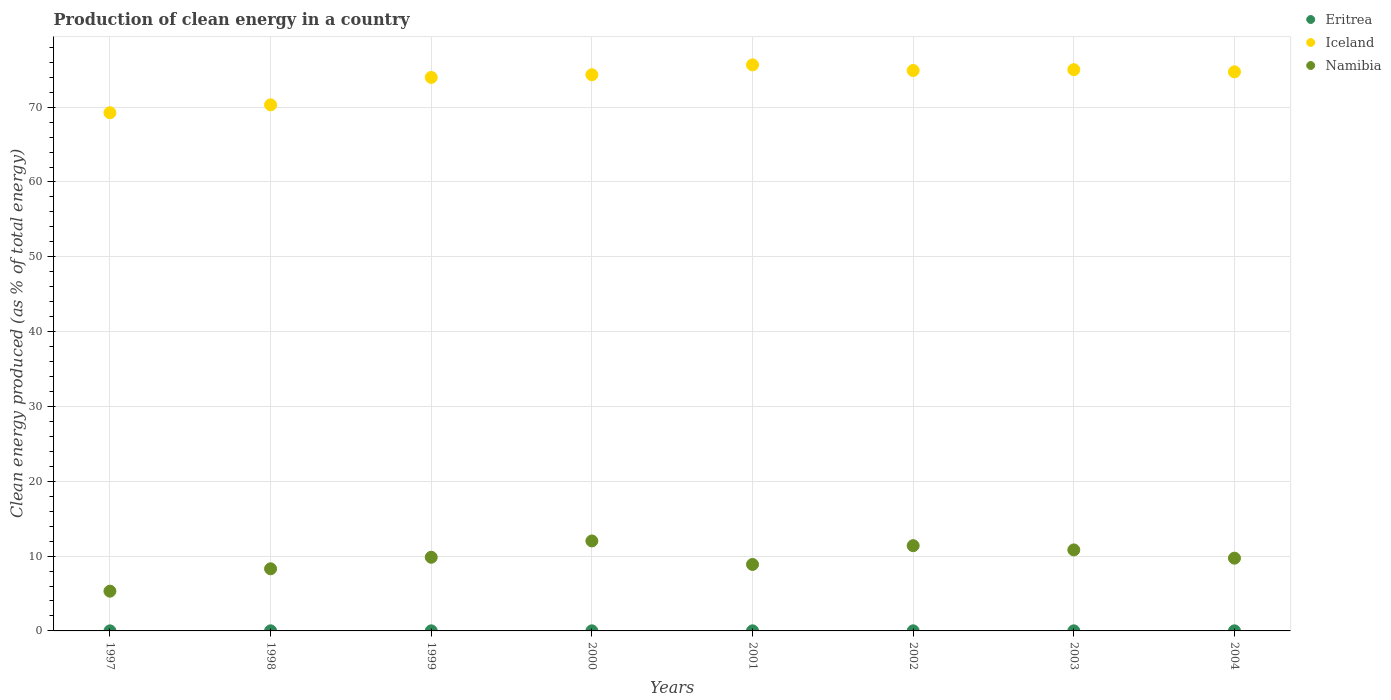How many different coloured dotlines are there?
Ensure brevity in your answer.  3. What is the percentage of clean energy produced in Eritrea in 2002?
Provide a short and direct response. 0.01. Across all years, what is the maximum percentage of clean energy produced in Namibia?
Provide a short and direct response. 12.02. Across all years, what is the minimum percentage of clean energy produced in Namibia?
Your answer should be compact. 5.31. In which year was the percentage of clean energy produced in Namibia maximum?
Provide a succinct answer. 2000. In which year was the percentage of clean energy produced in Eritrea minimum?
Ensure brevity in your answer.  1997. What is the total percentage of clean energy produced in Iceland in the graph?
Keep it short and to the point. 588.17. What is the difference between the percentage of clean energy produced in Eritrea in 1999 and that in 2001?
Keep it short and to the point. 0. What is the difference between the percentage of clean energy produced in Namibia in 1997 and the percentage of clean energy produced in Iceland in 1999?
Your answer should be compact. -68.66. What is the average percentage of clean energy produced in Eritrea per year?
Ensure brevity in your answer.  0.01. In the year 2001, what is the difference between the percentage of clean energy produced in Namibia and percentage of clean energy produced in Iceland?
Offer a terse response. -66.77. In how many years, is the percentage of clean energy produced in Iceland greater than 16 %?
Provide a short and direct response. 8. What is the ratio of the percentage of clean energy produced in Iceland in 1998 to that in 1999?
Your answer should be very brief. 0.95. Is the percentage of clean energy produced in Namibia in 1997 less than that in 2003?
Your response must be concise. Yes. What is the difference between the highest and the second highest percentage of clean energy produced in Eritrea?
Keep it short and to the point. 0. What is the difference between the highest and the lowest percentage of clean energy produced in Eritrea?
Offer a very short reply. 0. Is the sum of the percentage of clean energy produced in Namibia in 2003 and 2004 greater than the maximum percentage of clean energy produced in Iceland across all years?
Offer a very short reply. No. Is it the case that in every year, the sum of the percentage of clean energy produced in Namibia and percentage of clean energy produced in Eritrea  is greater than the percentage of clean energy produced in Iceland?
Your response must be concise. No. Does the percentage of clean energy produced in Namibia monotonically increase over the years?
Offer a very short reply. No. How many dotlines are there?
Give a very brief answer. 3. How many years are there in the graph?
Make the answer very short. 8. What is the difference between two consecutive major ticks on the Y-axis?
Offer a terse response. 10. Does the graph contain any zero values?
Your response must be concise. No. How many legend labels are there?
Give a very brief answer. 3. What is the title of the graph?
Your response must be concise. Production of clean energy in a country. Does "Low income" appear as one of the legend labels in the graph?
Keep it short and to the point. No. What is the label or title of the X-axis?
Offer a very short reply. Years. What is the label or title of the Y-axis?
Your response must be concise. Clean energy produced (as % of total energy). What is the Clean energy produced (as % of total energy) of Eritrea in 1997?
Provide a succinct answer. 0.01. What is the Clean energy produced (as % of total energy) of Iceland in 1997?
Give a very brief answer. 69.26. What is the Clean energy produced (as % of total energy) in Namibia in 1997?
Your response must be concise. 5.31. What is the Clean energy produced (as % of total energy) in Eritrea in 1998?
Make the answer very short. 0.01. What is the Clean energy produced (as % of total energy) in Iceland in 1998?
Offer a terse response. 70.31. What is the Clean energy produced (as % of total energy) of Namibia in 1998?
Provide a short and direct response. 8.3. What is the Clean energy produced (as % of total energy) of Eritrea in 1999?
Ensure brevity in your answer.  0.01. What is the Clean energy produced (as % of total energy) of Iceland in 1999?
Your answer should be compact. 73.98. What is the Clean energy produced (as % of total energy) of Namibia in 1999?
Provide a succinct answer. 9.84. What is the Clean energy produced (as % of total energy) of Eritrea in 2000?
Keep it short and to the point. 0.01. What is the Clean energy produced (as % of total energy) in Iceland in 2000?
Your answer should be compact. 74.33. What is the Clean energy produced (as % of total energy) in Namibia in 2000?
Ensure brevity in your answer.  12.02. What is the Clean energy produced (as % of total energy) of Eritrea in 2001?
Give a very brief answer. 0.01. What is the Clean energy produced (as % of total energy) in Iceland in 2001?
Keep it short and to the point. 75.65. What is the Clean energy produced (as % of total energy) of Namibia in 2001?
Make the answer very short. 8.89. What is the Clean energy produced (as % of total energy) of Eritrea in 2002?
Your response must be concise. 0.01. What is the Clean energy produced (as % of total energy) in Iceland in 2002?
Keep it short and to the point. 74.9. What is the Clean energy produced (as % of total energy) in Namibia in 2002?
Your response must be concise. 11.39. What is the Clean energy produced (as % of total energy) in Eritrea in 2003?
Give a very brief answer. 0.01. What is the Clean energy produced (as % of total energy) of Iceland in 2003?
Keep it short and to the point. 75.02. What is the Clean energy produced (as % of total energy) of Namibia in 2003?
Your response must be concise. 10.83. What is the Clean energy produced (as % of total energy) of Eritrea in 2004?
Provide a succinct answer. 0.01. What is the Clean energy produced (as % of total energy) in Iceland in 2004?
Keep it short and to the point. 74.72. What is the Clean energy produced (as % of total energy) in Namibia in 2004?
Your response must be concise. 9.72. Across all years, what is the maximum Clean energy produced (as % of total energy) in Eritrea?
Your answer should be very brief. 0.01. Across all years, what is the maximum Clean energy produced (as % of total energy) in Iceland?
Ensure brevity in your answer.  75.65. Across all years, what is the maximum Clean energy produced (as % of total energy) in Namibia?
Make the answer very short. 12.02. Across all years, what is the minimum Clean energy produced (as % of total energy) of Eritrea?
Offer a terse response. 0.01. Across all years, what is the minimum Clean energy produced (as % of total energy) of Iceland?
Your answer should be compact. 69.26. Across all years, what is the minimum Clean energy produced (as % of total energy) in Namibia?
Keep it short and to the point. 5.31. What is the total Clean energy produced (as % of total energy) of Eritrea in the graph?
Your answer should be compact. 0.09. What is the total Clean energy produced (as % of total energy) of Iceland in the graph?
Ensure brevity in your answer.  588.17. What is the total Clean energy produced (as % of total energy) in Namibia in the graph?
Provide a short and direct response. 76.31. What is the difference between the Clean energy produced (as % of total energy) of Eritrea in 1997 and that in 1998?
Make the answer very short. -0. What is the difference between the Clean energy produced (as % of total energy) of Iceland in 1997 and that in 1998?
Your response must be concise. -1.05. What is the difference between the Clean energy produced (as % of total energy) in Namibia in 1997 and that in 1998?
Keep it short and to the point. -2.99. What is the difference between the Clean energy produced (as % of total energy) in Eritrea in 1997 and that in 1999?
Offer a terse response. -0. What is the difference between the Clean energy produced (as % of total energy) in Iceland in 1997 and that in 1999?
Offer a terse response. -4.72. What is the difference between the Clean energy produced (as % of total energy) in Namibia in 1997 and that in 1999?
Provide a short and direct response. -4.53. What is the difference between the Clean energy produced (as % of total energy) in Eritrea in 1997 and that in 2000?
Ensure brevity in your answer.  -0. What is the difference between the Clean energy produced (as % of total energy) of Iceland in 1997 and that in 2000?
Offer a very short reply. -5.08. What is the difference between the Clean energy produced (as % of total energy) of Namibia in 1997 and that in 2000?
Keep it short and to the point. -6.71. What is the difference between the Clean energy produced (as % of total energy) in Eritrea in 1997 and that in 2001?
Make the answer very short. -0. What is the difference between the Clean energy produced (as % of total energy) in Iceland in 1997 and that in 2001?
Keep it short and to the point. -6.4. What is the difference between the Clean energy produced (as % of total energy) in Namibia in 1997 and that in 2001?
Keep it short and to the point. -3.57. What is the difference between the Clean energy produced (as % of total energy) of Eritrea in 1997 and that in 2002?
Offer a very short reply. -0. What is the difference between the Clean energy produced (as % of total energy) of Iceland in 1997 and that in 2002?
Offer a terse response. -5.65. What is the difference between the Clean energy produced (as % of total energy) of Namibia in 1997 and that in 2002?
Keep it short and to the point. -6.08. What is the difference between the Clean energy produced (as % of total energy) in Eritrea in 1997 and that in 2003?
Make the answer very short. -0. What is the difference between the Clean energy produced (as % of total energy) in Iceland in 1997 and that in 2003?
Provide a short and direct response. -5.76. What is the difference between the Clean energy produced (as % of total energy) of Namibia in 1997 and that in 2003?
Your answer should be compact. -5.51. What is the difference between the Clean energy produced (as % of total energy) of Eritrea in 1997 and that in 2004?
Keep it short and to the point. -0. What is the difference between the Clean energy produced (as % of total energy) in Iceland in 1997 and that in 2004?
Your answer should be very brief. -5.47. What is the difference between the Clean energy produced (as % of total energy) in Namibia in 1997 and that in 2004?
Give a very brief answer. -4.41. What is the difference between the Clean energy produced (as % of total energy) of Eritrea in 1998 and that in 1999?
Offer a very short reply. 0. What is the difference between the Clean energy produced (as % of total energy) in Iceland in 1998 and that in 1999?
Your response must be concise. -3.66. What is the difference between the Clean energy produced (as % of total energy) in Namibia in 1998 and that in 1999?
Provide a short and direct response. -1.54. What is the difference between the Clean energy produced (as % of total energy) of Eritrea in 1998 and that in 2000?
Offer a terse response. 0. What is the difference between the Clean energy produced (as % of total energy) of Iceland in 1998 and that in 2000?
Provide a succinct answer. -4.02. What is the difference between the Clean energy produced (as % of total energy) in Namibia in 1998 and that in 2000?
Provide a short and direct response. -3.72. What is the difference between the Clean energy produced (as % of total energy) of Eritrea in 1998 and that in 2001?
Your answer should be compact. 0. What is the difference between the Clean energy produced (as % of total energy) of Iceland in 1998 and that in 2001?
Your answer should be very brief. -5.34. What is the difference between the Clean energy produced (as % of total energy) of Namibia in 1998 and that in 2001?
Keep it short and to the point. -0.58. What is the difference between the Clean energy produced (as % of total energy) in Eritrea in 1998 and that in 2002?
Provide a short and direct response. 0. What is the difference between the Clean energy produced (as % of total energy) in Iceland in 1998 and that in 2002?
Keep it short and to the point. -4.59. What is the difference between the Clean energy produced (as % of total energy) in Namibia in 1998 and that in 2002?
Keep it short and to the point. -3.09. What is the difference between the Clean energy produced (as % of total energy) in Eritrea in 1998 and that in 2003?
Ensure brevity in your answer.  0. What is the difference between the Clean energy produced (as % of total energy) of Iceland in 1998 and that in 2003?
Your response must be concise. -4.7. What is the difference between the Clean energy produced (as % of total energy) of Namibia in 1998 and that in 2003?
Your answer should be very brief. -2.52. What is the difference between the Clean energy produced (as % of total energy) of Eritrea in 1998 and that in 2004?
Give a very brief answer. 0. What is the difference between the Clean energy produced (as % of total energy) in Iceland in 1998 and that in 2004?
Provide a short and direct response. -4.41. What is the difference between the Clean energy produced (as % of total energy) of Namibia in 1998 and that in 2004?
Your response must be concise. -1.42. What is the difference between the Clean energy produced (as % of total energy) in Eritrea in 1999 and that in 2000?
Provide a succinct answer. 0. What is the difference between the Clean energy produced (as % of total energy) in Iceland in 1999 and that in 2000?
Make the answer very short. -0.36. What is the difference between the Clean energy produced (as % of total energy) in Namibia in 1999 and that in 2000?
Provide a short and direct response. -2.18. What is the difference between the Clean energy produced (as % of total energy) of Eritrea in 1999 and that in 2001?
Offer a very short reply. 0. What is the difference between the Clean energy produced (as % of total energy) in Iceland in 1999 and that in 2001?
Keep it short and to the point. -1.68. What is the difference between the Clean energy produced (as % of total energy) in Namibia in 1999 and that in 2001?
Provide a succinct answer. 0.96. What is the difference between the Clean energy produced (as % of total energy) of Eritrea in 1999 and that in 2002?
Offer a very short reply. 0. What is the difference between the Clean energy produced (as % of total energy) of Iceland in 1999 and that in 2002?
Your response must be concise. -0.93. What is the difference between the Clean energy produced (as % of total energy) of Namibia in 1999 and that in 2002?
Your answer should be very brief. -1.55. What is the difference between the Clean energy produced (as % of total energy) of Eritrea in 1999 and that in 2003?
Provide a short and direct response. 0. What is the difference between the Clean energy produced (as % of total energy) of Iceland in 1999 and that in 2003?
Your response must be concise. -1.04. What is the difference between the Clean energy produced (as % of total energy) of Namibia in 1999 and that in 2003?
Give a very brief answer. -0.98. What is the difference between the Clean energy produced (as % of total energy) in Eritrea in 1999 and that in 2004?
Provide a succinct answer. 0. What is the difference between the Clean energy produced (as % of total energy) in Iceland in 1999 and that in 2004?
Your response must be concise. -0.75. What is the difference between the Clean energy produced (as % of total energy) of Namibia in 1999 and that in 2004?
Your answer should be very brief. 0.12. What is the difference between the Clean energy produced (as % of total energy) of Eritrea in 2000 and that in 2001?
Provide a short and direct response. 0. What is the difference between the Clean energy produced (as % of total energy) in Iceland in 2000 and that in 2001?
Your answer should be very brief. -1.32. What is the difference between the Clean energy produced (as % of total energy) in Namibia in 2000 and that in 2001?
Provide a succinct answer. 3.14. What is the difference between the Clean energy produced (as % of total energy) in Eritrea in 2000 and that in 2002?
Provide a short and direct response. 0. What is the difference between the Clean energy produced (as % of total energy) of Iceland in 2000 and that in 2002?
Provide a succinct answer. -0.57. What is the difference between the Clean energy produced (as % of total energy) of Namibia in 2000 and that in 2002?
Give a very brief answer. 0.63. What is the difference between the Clean energy produced (as % of total energy) in Eritrea in 2000 and that in 2003?
Offer a very short reply. 0. What is the difference between the Clean energy produced (as % of total energy) in Iceland in 2000 and that in 2003?
Give a very brief answer. -0.68. What is the difference between the Clean energy produced (as % of total energy) of Namibia in 2000 and that in 2003?
Your answer should be compact. 1.2. What is the difference between the Clean energy produced (as % of total energy) of Eritrea in 2000 and that in 2004?
Offer a terse response. 0. What is the difference between the Clean energy produced (as % of total energy) of Iceland in 2000 and that in 2004?
Ensure brevity in your answer.  -0.39. What is the difference between the Clean energy produced (as % of total energy) of Namibia in 2000 and that in 2004?
Your answer should be very brief. 2.3. What is the difference between the Clean energy produced (as % of total energy) of Iceland in 2001 and that in 2002?
Make the answer very short. 0.75. What is the difference between the Clean energy produced (as % of total energy) of Namibia in 2001 and that in 2002?
Give a very brief answer. -2.51. What is the difference between the Clean energy produced (as % of total energy) of Eritrea in 2001 and that in 2003?
Offer a very short reply. 0. What is the difference between the Clean energy produced (as % of total energy) of Iceland in 2001 and that in 2003?
Make the answer very short. 0.64. What is the difference between the Clean energy produced (as % of total energy) of Namibia in 2001 and that in 2003?
Make the answer very short. -1.94. What is the difference between the Clean energy produced (as % of total energy) of Eritrea in 2001 and that in 2004?
Your answer should be very brief. 0. What is the difference between the Clean energy produced (as % of total energy) of Iceland in 2001 and that in 2004?
Keep it short and to the point. 0.93. What is the difference between the Clean energy produced (as % of total energy) in Namibia in 2001 and that in 2004?
Give a very brief answer. -0.84. What is the difference between the Clean energy produced (as % of total energy) of Eritrea in 2002 and that in 2003?
Offer a very short reply. 0. What is the difference between the Clean energy produced (as % of total energy) in Iceland in 2002 and that in 2003?
Your response must be concise. -0.11. What is the difference between the Clean energy produced (as % of total energy) of Namibia in 2002 and that in 2003?
Offer a very short reply. 0.57. What is the difference between the Clean energy produced (as % of total energy) of Eritrea in 2002 and that in 2004?
Offer a terse response. -0. What is the difference between the Clean energy produced (as % of total energy) of Iceland in 2002 and that in 2004?
Offer a terse response. 0.18. What is the difference between the Clean energy produced (as % of total energy) of Namibia in 2002 and that in 2004?
Ensure brevity in your answer.  1.67. What is the difference between the Clean energy produced (as % of total energy) of Eritrea in 2003 and that in 2004?
Offer a very short reply. -0. What is the difference between the Clean energy produced (as % of total energy) in Iceland in 2003 and that in 2004?
Your response must be concise. 0.29. What is the difference between the Clean energy produced (as % of total energy) of Namibia in 2003 and that in 2004?
Your answer should be compact. 1.1. What is the difference between the Clean energy produced (as % of total energy) of Eritrea in 1997 and the Clean energy produced (as % of total energy) of Iceland in 1998?
Your response must be concise. -70.3. What is the difference between the Clean energy produced (as % of total energy) in Eritrea in 1997 and the Clean energy produced (as % of total energy) in Namibia in 1998?
Your answer should be very brief. -8.3. What is the difference between the Clean energy produced (as % of total energy) of Iceland in 1997 and the Clean energy produced (as % of total energy) of Namibia in 1998?
Your answer should be compact. 60.95. What is the difference between the Clean energy produced (as % of total energy) in Eritrea in 1997 and the Clean energy produced (as % of total energy) in Iceland in 1999?
Your answer should be very brief. -73.97. What is the difference between the Clean energy produced (as % of total energy) of Eritrea in 1997 and the Clean energy produced (as % of total energy) of Namibia in 1999?
Your response must be concise. -9.83. What is the difference between the Clean energy produced (as % of total energy) of Iceland in 1997 and the Clean energy produced (as % of total energy) of Namibia in 1999?
Provide a succinct answer. 59.41. What is the difference between the Clean energy produced (as % of total energy) in Eritrea in 1997 and the Clean energy produced (as % of total energy) in Iceland in 2000?
Ensure brevity in your answer.  -74.33. What is the difference between the Clean energy produced (as % of total energy) of Eritrea in 1997 and the Clean energy produced (as % of total energy) of Namibia in 2000?
Your response must be concise. -12.01. What is the difference between the Clean energy produced (as % of total energy) of Iceland in 1997 and the Clean energy produced (as % of total energy) of Namibia in 2000?
Offer a very short reply. 57.23. What is the difference between the Clean energy produced (as % of total energy) of Eritrea in 1997 and the Clean energy produced (as % of total energy) of Iceland in 2001?
Provide a succinct answer. -75.64. What is the difference between the Clean energy produced (as % of total energy) in Eritrea in 1997 and the Clean energy produced (as % of total energy) in Namibia in 2001?
Give a very brief answer. -8.88. What is the difference between the Clean energy produced (as % of total energy) in Iceland in 1997 and the Clean energy produced (as % of total energy) in Namibia in 2001?
Keep it short and to the point. 60.37. What is the difference between the Clean energy produced (as % of total energy) in Eritrea in 1997 and the Clean energy produced (as % of total energy) in Iceland in 2002?
Your answer should be very brief. -74.89. What is the difference between the Clean energy produced (as % of total energy) of Eritrea in 1997 and the Clean energy produced (as % of total energy) of Namibia in 2002?
Provide a short and direct response. -11.39. What is the difference between the Clean energy produced (as % of total energy) of Iceland in 1997 and the Clean energy produced (as % of total energy) of Namibia in 2002?
Provide a succinct answer. 57.86. What is the difference between the Clean energy produced (as % of total energy) in Eritrea in 1997 and the Clean energy produced (as % of total energy) in Iceland in 2003?
Give a very brief answer. -75.01. What is the difference between the Clean energy produced (as % of total energy) of Eritrea in 1997 and the Clean energy produced (as % of total energy) of Namibia in 2003?
Your answer should be compact. -10.82. What is the difference between the Clean energy produced (as % of total energy) in Iceland in 1997 and the Clean energy produced (as % of total energy) in Namibia in 2003?
Ensure brevity in your answer.  58.43. What is the difference between the Clean energy produced (as % of total energy) in Eritrea in 1997 and the Clean energy produced (as % of total energy) in Iceland in 2004?
Offer a very short reply. -74.72. What is the difference between the Clean energy produced (as % of total energy) in Eritrea in 1997 and the Clean energy produced (as % of total energy) in Namibia in 2004?
Ensure brevity in your answer.  -9.72. What is the difference between the Clean energy produced (as % of total energy) in Iceland in 1997 and the Clean energy produced (as % of total energy) in Namibia in 2004?
Give a very brief answer. 59.53. What is the difference between the Clean energy produced (as % of total energy) in Eritrea in 1998 and the Clean energy produced (as % of total energy) in Iceland in 1999?
Your answer should be very brief. -73.96. What is the difference between the Clean energy produced (as % of total energy) of Eritrea in 1998 and the Clean energy produced (as % of total energy) of Namibia in 1999?
Ensure brevity in your answer.  -9.83. What is the difference between the Clean energy produced (as % of total energy) of Iceland in 1998 and the Clean energy produced (as % of total energy) of Namibia in 1999?
Your response must be concise. 60.47. What is the difference between the Clean energy produced (as % of total energy) of Eritrea in 1998 and the Clean energy produced (as % of total energy) of Iceland in 2000?
Make the answer very short. -74.32. What is the difference between the Clean energy produced (as % of total energy) in Eritrea in 1998 and the Clean energy produced (as % of total energy) in Namibia in 2000?
Offer a terse response. -12.01. What is the difference between the Clean energy produced (as % of total energy) in Iceland in 1998 and the Clean energy produced (as % of total energy) in Namibia in 2000?
Provide a short and direct response. 58.29. What is the difference between the Clean energy produced (as % of total energy) of Eritrea in 1998 and the Clean energy produced (as % of total energy) of Iceland in 2001?
Offer a terse response. -75.64. What is the difference between the Clean energy produced (as % of total energy) of Eritrea in 1998 and the Clean energy produced (as % of total energy) of Namibia in 2001?
Ensure brevity in your answer.  -8.87. What is the difference between the Clean energy produced (as % of total energy) in Iceland in 1998 and the Clean energy produced (as % of total energy) in Namibia in 2001?
Provide a succinct answer. 61.43. What is the difference between the Clean energy produced (as % of total energy) in Eritrea in 1998 and the Clean energy produced (as % of total energy) in Iceland in 2002?
Your response must be concise. -74.89. What is the difference between the Clean energy produced (as % of total energy) of Eritrea in 1998 and the Clean energy produced (as % of total energy) of Namibia in 2002?
Give a very brief answer. -11.38. What is the difference between the Clean energy produced (as % of total energy) in Iceland in 1998 and the Clean energy produced (as % of total energy) in Namibia in 2002?
Give a very brief answer. 58.92. What is the difference between the Clean energy produced (as % of total energy) in Eritrea in 1998 and the Clean energy produced (as % of total energy) in Iceland in 2003?
Give a very brief answer. -75. What is the difference between the Clean energy produced (as % of total energy) in Eritrea in 1998 and the Clean energy produced (as % of total energy) in Namibia in 2003?
Keep it short and to the point. -10.81. What is the difference between the Clean energy produced (as % of total energy) of Iceland in 1998 and the Clean energy produced (as % of total energy) of Namibia in 2003?
Your answer should be very brief. 59.49. What is the difference between the Clean energy produced (as % of total energy) in Eritrea in 1998 and the Clean energy produced (as % of total energy) in Iceland in 2004?
Offer a very short reply. -74.71. What is the difference between the Clean energy produced (as % of total energy) of Eritrea in 1998 and the Clean energy produced (as % of total energy) of Namibia in 2004?
Provide a succinct answer. -9.71. What is the difference between the Clean energy produced (as % of total energy) of Iceland in 1998 and the Clean energy produced (as % of total energy) of Namibia in 2004?
Ensure brevity in your answer.  60.59. What is the difference between the Clean energy produced (as % of total energy) in Eritrea in 1999 and the Clean energy produced (as % of total energy) in Iceland in 2000?
Give a very brief answer. -74.32. What is the difference between the Clean energy produced (as % of total energy) in Eritrea in 1999 and the Clean energy produced (as % of total energy) in Namibia in 2000?
Ensure brevity in your answer.  -12.01. What is the difference between the Clean energy produced (as % of total energy) in Iceland in 1999 and the Clean energy produced (as % of total energy) in Namibia in 2000?
Your answer should be very brief. 61.95. What is the difference between the Clean energy produced (as % of total energy) of Eritrea in 1999 and the Clean energy produced (as % of total energy) of Iceland in 2001?
Offer a terse response. -75.64. What is the difference between the Clean energy produced (as % of total energy) of Eritrea in 1999 and the Clean energy produced (as % of total energy) of Namibia in 2001?
Give a very brief answer. -8.87. What is the difference between the Clean energy produced (as % of total energy) of Iceland in 1999 and the Clean energy produced (as % of total energy) of Namibia in 2001?
Offer a very short reply. 65.09. What is the difference between the Clean energy produced (as % of total energy) of Eritrea in 1999 and the Clean energy produced (as % of total energy) of Iceland in 2002?
Make the answer very short. -74.89. What is the difference between the Clean energy produced (as % of total energy) in Eritrea in 1999 and the Clean energy produced (as % of total energy) in Namibia in 2002?
Give a very brief answer. -11.38. What is the difference between the Clean energy produced (as % of total energy) in Iceland in 1999 and the Clean energy produced (as % of total energy) in Namibia in 2002?
Provide a succinct answer. 62.58. What is the difference between the Clean energy produced (as % of total energy) of Eritrea in 1999 and the Clean energy produced (as % of total energy) of Iceland in 2003?
Make the answer very short. -75. What is the difference between the Clean energy produced (as % of total energy) in Eritrea in 1999 and the Clean energy produced (as % of total energy) in Namibia in 2003?
Offer a terse response. -10.81. What is the difference between the Clean energy produced (as % of total energy) in Iceland in 1999 and the Clean energy produced (as % of total energy) in Namibia in 2003?
Make the answer very short. 63.15. What is the difference between the Clean energy produced (as % of total energy) of Eritrea in 1999 and the Clean energy produced (as % of total energy) of Iceland in 2004?
Your answer should be very brief. -74.71. What is the difference between the Clean energy produced (as % of total energy) in Eritrea in 1999 and the Clean energy produced (as % of total energy) in Namibia in 2004?
Ensure brevity in your answer.  -9.71. What is the difference between the Clean energy produced (as % of total energy) in Iceland in 1999 and the Clean energy produced (as % of total energy) in Namibia in 2004?
Give a very brief answer. 64.25. What is the difference between the Clean energy produced (as % of total energy) of Eritrea in 2000 and the Clean energy produced (as % of total energy) of Iceland in 2001?
Make the answer very short. -75.64. What is the difference between the Clean energy produced (as % of total energy) of Eritrea in 2000 and the Clean energy produced (as % of total energy) of Namibia in 2001?
Ensure brevity in your answer.  -8.87. What is the difference between the Clean energy produced (as % of total energy) of Iceland in 2000 and the Clean energy produced (as % of total energy) of Namibia in 2001?
Offer a terse response. 65.45. What is the difference between the Clean energy produced (as % of total energy) in Eritrea in 2000 and the Clean energy produced (as % of total energy) in Iceland in 2002?
Give a very brief answer. -74.89. What is the difference between the Clean energy produced (as % of total energy) of Eritrea in 2000 and the Clean energy produced (as % of total energy) of Namibia in 2002?
Provide a succinct answer. -11.38. What is the difference between the Clean energy produced (as % of total energy) in Iceland in 2000 and the Clean energy produced (as % of total energy) in Namibia in 2002?
Provide a short and direct response. 62.94. What is the difference between the Clean energy produced (as % of total energy) of Eritrea in 2000 and the Clean energy produced (as % of total energy) of Iceland in 2003?
Offer a very short reply. -75. What is the difference between the Clean energy produced (as % of total energy) in Eritrea in 2000 and the Clean energy produced (as % of total energy) in Namibia in 2003?
Offer a very short reply. -10.81. What is the difference between the Clean energy produced (as % of total energy) of Iceland in 2000 and the Clean energy produced (as % of total energy) of Namibia in 2003?
Provide a short and direct response. 63.51. What is the difference between the Clean energy produced (as % of total energy) of Eritrea in 2000 and the Clean energy produced (as % of total energy) of Iceland in 2004?
Provide a short and direct response. -74.71. What is the difference between the Clean energy produced (as % of total energy) in Eritrea in 2000 and the Clean energy produced (as % of total energy) in Namibia in 2004?
Offer a very short reply. -9.71. What is the difference between the Clean energy produced (as % of total energy) of Iceland in 2000 and the Clean energy produced (as % of total energy) of Namibia in 2004?
Offer a very short reply. 64.61. What is the difference between the Clean energy produced (as % of total energy) in Eritrea in 2001 and the Clean energy produced (as % of total energy) in Iceland in 2002?
Your response must be concise. -74.89. What is the difference between the Clean energy produced (as % of total energy) in Eritrea in 2001 and the Clean energy produced (as % of total energy) in Namibia in 2002?
Your response must be concise. -11.38. What is the difference between the Clean energy produced (as % of total energy) in Iceland in 2001 and the Clean energy produced (as % of total energy) in Namibia in 2002?
Keep it short and to the point. 64.26. What is the difference between the Clean energy produced (as % of total energy) in Eritrea in 2001 and the Clean energy produced (as % of total energy) in Iceland in 2003?
Provide a short and direct response. -75. What is the difference between the Clean energy produced (as % of total energy) of Eritrea in 2001 and the Clean energy produced (as % of total energy) of Namibia in 2003?
Offer a very short reply. -10.81. What is the difference between the Clean energy produced (as % of total energy) in Iceland in 2001 and the Clean energy produced (as % of total energy) in Namibia in 2003?
Provide a succinct answer. 64.83. What is the difference between the Clean energy produced (as % of total energy) in Eritrea in 2001 and the Clean energy produced (as % of total energy) in Iceland in 2004?
Ensure brevity in your answer.  -74.71. What is the difference between the Clean energy produced (as % of total energy) of Eritrea in 2001 and the Clean energy produced (as % of total energy) of Namibia in 2004?
Provide a short and direct response. -9.71. What is the difference between the Clean energy produced (as % of total energy) in Iceland in 2001 and the Clean energy produced (as % of total energy) in Namibia in 2004?
Give a very brief answer. 65.93. What is the difference between the Clean energy produced (as % of total energy) in Eritrea in 2002 and the Clean energy produced (as % of total energy) in Iceland in 2003?
Keep it short and to the point. -75. What is the difference between the Clean energy produced (as % of total energy) in Eritrea in 2002 and the Clean energy produced (as % of total energy) in Namibia in 2003?
Offer a terse response. -10.81. What is the difference between the Clean energy produced (as % of total energy) of Iceland in 2002 and the Clean energy produced (as % of total energy) of Namibia in 2003?
Offer a very short reply. 64.08. What is the difference between the Clean energy produced (as % of total energy) of Eritrea in 2002 and the Clean energy produced (as % of total energy) of Iceland in 2004?
Your response must be concise. -74.71. What is the difference between the Clean energy produced (as % of total energy) of Eritrea in 2002 and the Clean energy produced (as % of total energy) of Namibia in 2004?
Offer a terse response. -9.71. What is the difference between the Clean energy produced (as % of total energy) in Iceland in 2002 and the Clean energy produced (as % of total energy) in Namibia in 2004?
Provide a succinct answer. 65.18. What is the difference between the Clean energy produced (as % of total energy) in Eritrea in 2003 and the Clean energy produced (as % of total energy) in Iceland in 2004?
Your response must be concise. -74.71. What is the difference between the Clean energy produced (as % of total energy) of Eritrea in 2003 and the Clean energy produced (as % of total energy) of Namibia in 2004?
Provide a short and direct response. -9.71. What is the difference between the Clean energy produced (as % of total energy) of Iceland in 2003 and the Clean energy produced (as % of total energy) of Namibia in 2004?
Your answer should be compact. 65.29. What is the average Clean energy produced (as % of total energy) of Eritrea per year?
Ensure brevity in your answer.  0.01. What is the average Clean energy produced (as % of total energy) in Iceland per year?
Give a very brief answer. 73.52. What is the average Clean energy produced (as % of total energy) of Namibia per year?
Give a very brief answer. 9.54. In the year 1997, what is the difference between the Clean energy produced (as % of total energy) of Eritrea and Clean energy produced (as % of total energy) of Iceland?
Your response must be concise. -69.25. In the year 1997, what is the difference between the Clean energy produced (as % of total energy) of Eritrea and Clean energy produced (as % of total energy) of Namibia?
Ensure brevity in your answer.  -5.3. In the year 1997, what is the difference between the Clean energy produced (as % of total energy) in Iceland and Clean energy produced (as % of total energy) in Namibia?
Your answer should be compact. 63.94. In the year 1998, what is the difference between the Clean energy produced (as % of total energy) of Eritrea and Clean energy produced (as % of total energy) of Iceland?
Provide a succinct answer. -70.3. In the year 1998, what is the difference between the Clean energy produced (as % of total energy) in Eritrea and Clean energy produced (as % of total energy) in Namibia?
Offer a very short reply. -8.29. In the year 1998, what is the difference between the Clean energy produced (as % of total energy) of Iceland and Clean energy produced (as % of total energy) of Namibia?
Your answer should be compact. 62.01. In the year 1999, what is the difference between the Clean energy produced (as % of total energy) in Eritrea and Clean energy produced (as % of total energy) in Iceland?
Provide a succinct answer. -73.96. In the year 1999, what is the difference between the Clean energy produced (as % of total energy) in Eritrea and Clean energy produced (as % of total energy) in Namibia?
Make the answer very short. -9.83. In the year 1999, what is the difference between the Clean energy produced (as % of total energy) of Iceland and Clean energy produced (as % of total energy) of Namibia?
Offer a very short reply. 64.13. In the year 2000, what is the difference between the Clean energy produced (as % of total energy) in Eritrea and Clean energy produced (as % of total energy) in Iceland?
Provide a short and direct response. -74.32. In the year 2000, what is the difference between the Clean energy produced (as % of total energy) in Eritrea and Clean energy produced (as % of total energy) in Namibia?
Give a very brief answer. -12.01. In the year 2000, what is the difference between the Clean energy produced (as % of total energy) of Iceland and Clean energy produced (as % of total energy) of Namibia?
Your response must be concise. 62.31. In the year 2001, what is the difference between the Clean energy produced (as % of total energy) of Eritrea and Clean energy produced (as % of total energy) of Iceland?
Make the answer very short. -75.64. In the year 2001, what is the difference between the Clean energy produced (as % of total energy) of Eritrea and Clean energy produced (as % of total energy) of Namibia?
Provide a short and direct response. -8.87. In the year 2001, what is the difference between the Clean energy produced (as % of total energy) in Iceland and Clean energy produced (as % of total energy) in Namibia?
Your answer should be compact. 66.77. In the year 2002, what is the difference between the Clean energy produced (as % of total energy) of Eritrea and Clean energy produced (as % of total energy) of Iceland?
Offer a terse response. -74.89. In the year 2002, what is the difference between the Clean energy produced (as % of total energy) in Eritrea and Clean energy produced (as % of total energy) in Namibia?
Make the answer very short. -11.38. In the year 2002, what is the difference between the Clean energy produced (as % of total energy) of Iceland and Clean energy produced (as % of total energy) of Namibia?
Ensure brevity in your answer.  63.51. In the year 2003, what is the difference between the Clean energy produced (as % of total energy) of Eritrea and Clean energy produced (as % of total energy) of Iceland?
Your answer should be compact. -75. In the year 2003, what is the difference between the Clean energy produced (as % of total energy) in Eritrea and Clean energy produced (as % of total energy) in Namibia?
Give a very brief answer. -10.82. In the year 2003, what is the difference between the Clean energy produced (as % of total energy) in Iceland and Clean energy produced (as % of total energy) in Namibia?
Make the answer very short. 64.19. In the year 2004, what is the difference between the Clean energy produced (as % of total energy) of Eritrea and Clean energy produced (as % of total energy) of Iceland?
Offer a terse response. -74.71. In the year 2004, what is the difference between the Clean energy produced (as % of total energy) of Eritrea and Clean energy produced (as % of total energy) of Namibia?
Provide a succinct answer. -9.71. In the year 2004, what is the difference between the Clean energy produced (as % of total energy) in Iceland and Clean energy produced (as % of total energy) in Namibia?
Offer a terse response. 65. What is the ratio of the Clean energy produced (as % of total energy) of Eritrea in 1997 to that in 1998?
Your answer should be very brief. 0.65. What is the ratio of the Clean energy produced (as % of total energy) in Iceland in 1997 to that in 1998?
Offer a very short reply. 0.98. What is the ratio of the Clean energy produced (as % of total energy) of Namibia in 1997 to that in 1998?
Your response must be concise. 0.64. What is the ratio of the Clean energy produced (as % of total energy) of Eritrea in 1997 to that in 1999?
Provide a short and direct response. 0.67. What is the ratio of the Clean energy produced (as % of total energy) in Iceland in 1997 to that in 1999?
Ensure brevity in your answer.  0.94. What is the ratio of the Clean energy produced (as % of total energy) in Namibia in 1997 to that in 1999?
Your response must be concise. 0.54. What is the ratio of the Clean energy produced (as % of total energy) of Eritrea in 1997 to that in 2000?
Keep it short and to the point. 0.68. What is the ratio of the Clean energy produced (as % of total energy) of Iceland in 1997 to that in 2000?
Ensure brevity in your answer.  0.93. What is the ratio of the Clean energy produced (as % of total energy) of Namibia in 1997 to that in 2000?
Ensure brevity in your answer.  0.44. What is the ratio of the Clean energy produced (as % of total energy) of Eritrea in 1997 to that in 2001?
Provide a succinct answer. 0.71. What is the ratio of the Clean energy produced (as % of total energy) of Iceland in 1997 to that in 2001?
Make the answer very short. 0.92. What is the ratio of the Clean energy produced (as % of total energy) of Namibia in 1997 to that in 2001?
Keep it short and to the point. 0.6. What is the ratio of the Clean energy produced (as % of total energy) in Eritrea in 1997 to that in 2002?
Your answer should be very brief. 0.72. What is the ratio of the Clean energy produced (as % of total energy) of Iceland in 1997 to that in 2002?
Give a very brief answer. 0.92. What is the ratio of the Clean energy produced (as % of total energy) of Namibia in 1997 to that in 2002?
Give a very brief answer. 0.47. What is the ratio of the Clean energy produced (as % of total energy) of Eritrea in 1997 to that in 2003?
Provide a short and direct response. 0.77. What is the ratio of the Clean energy produced (as % of total energy) of Iceland in 1997 to that in 2003?
Ensure brevity in your answer.  0.92. What is the ratio of the Clean energy produced (as % of total energy) in Namibia in 1997 to that in 2003?
Offer a terse response. 0.49. What is the ratio of the Clean energy produced (as % of total energy) of Eritrea in 1997 to that in 2004?
Keep it short and to the point. 0.71. What is the ratio of the Clean energy produced (as % of total energy) in Iceland in 1997 to that in 2004?
Provide a short and direct response. 0.93. What is the ratio of the Clean energy produced (as % of total energy) in Namibia in 1997 to that in 2004?
Provide a short and direct response. 0.55. What is the ratio of the Clean energy produced (as % of total energy) in Eritrea in 1998 to that in 1999?
Make the answer very short. 1.04. What is the ratio of the Clean energy produced (as % of total energy) of Iceland in 1998 to that in 1999?
Provide a short and direct response. 0.95. What is the ratio of the Clean energy produced (as % of total energy) in Namibia in 1998 to that in 1999?
Offer a very short reply. 0.84. What is the ratio of the Clean energy produced (as % of total energy) in Eritrea in 1998 to that in 2000?
Your answer should be very brief. 1.05. What is the ratio of the Clean energy produced (as % of total energy) of Iceland in 1998 to that in 2000?
Your answer should be compact. 0.95. What is the ratio of the Clean energy produced (as % of total energy) of Namibia in 1998 to that in 2000?
Provide a succinct answer. 0.69. What is the ratio of the Clean energy produced (as % of total energy) of Eritrea in 1998 to that in 2001?
Offer a terse response. 1.1. What is the ratio of the Clean energy produced (as % of total energy) of Iceland in 1998 to that in 2001?
Your answer should be very brief. 0.93. What is the ratio of the Clean energy produced (as % of total energy) of Namibia in 1998 to that in 2001?
Offer a very short reply. 0.93. What is the ratio of the Clean energy produced (as % of total energy) in Eritrea in 1998 to that in 2002?
Give a very brief answer. 1.11. What is the ratio of the Clean energy produced (as % of total energy) in Iceland in 1998 to that in 2002?
Your answer should be very brief. 0.94. What is the ratio of the Clean energy produced (as % of total energy) in Namibia in 1998 to that in 2002?
Offer a terse response. 0.73. What is the ratio of the Clean energy produced (as % of total energy) in Eritrea in 1998 to that in 2003?
Give a very brief answer. 1.19. What is the ratio of the Clean energy produced (as % of total energy) in Iceland in 1998 to that in 2003?
Your answer should be very brief. 0.94. What is the ratio of the Clean energy produced (as % of total energy) in Namibia in 1998 to that in 2003?
Keep it short and to the point. 0.77. What is the ratio of the Clean energy produced (as % of total energy) of Eritrea in 1998 to that in 2004?
Provide a succinct answer. 1.1. What is the ratio of the Clean energy produced (as % of total energy) of Iceland in 1998 to that in 2004?
Provide a short and direct response. 0.94. What is the ratio of the Clean energy produced (as % of total energy) in Namibia in 1998 to that in 2004?
Offer a very short reply. 0.85. What is the ratio of the Clean energy produced (as % of total energy) of Eritrea in 1999 to that in 2000?
Your answer should be very brief. 1.01. What is the ratio of the Clean energy produced (as % of total energy) in Namibia in 1999 to that in 2000?
Your answer should be compact. 0.82. What is the ratio of the Clean energy produced (as % of total energy) in Eritrea in 1999 to that in 2001?
Offer a very short reply. 1.06. What is the ratio of the Clean energy produced (as % of total energy) of Iceland in 1999 to that in 2001?
Provide a succinct answer. 0.98. What is the ratio of the Clean energy produced (as % of total energy) of Namibia in 1999 to that in 2001?
Offer a terse response. 1.11. What is the ratio of the Clean energy produced (as % of total energy) of Eritrea in 1999 to that in 2002?
Offer a very short reply. 1.07. What is the ratio of the Clean energy produced (as % of total energy) in Iceland in 1999 to that in 2002?
Ensure brevity in your answer.  0.99. What is the ratio of the Clean energy produced (as % of total energy) in Namibia in 1999 to that in 2002?
Offer a terse response. 0.86. What is the ratio of the Clean energy produced (as % of total energy) of Eritrea in 1999 to that in 2003?
Offer a very short reply. 1.15. What is the ratio of the Clean energy produced (as % of total energy) of Iceland in 1999 to that in 2003?
Keep it short and to the point. 0.99. What is the ratio of the Clean energy produced (as % of total energy) of Namibia in 1999 to that in 2003?
Your response must be concise. 0.91. What is the ratio of the Clean energy produced (as % of total energy) in Eritrea in 1999 to that in 2004?
Offer a terse response. 1.06. What is the ratio of the Clean energy produced (as % of total energy) of Namibia in 1999 to that in 2004?
Your response must be concise. 1.01. What is the ratio of the Clean energy produced (as % of total energy) of Eritrea in 2000 to that in 2001?
Your answer should be compact. 1.05. What is the ratio of the Clean energy produced (as % of total energy) in Iceland in 2000 to that in 2001?
Your response must be concise. 0.98. What is the ratio of the Clean energy produced (as % of total energy) in Namibia in 2000 to that in 2001?
Offer a terse response. 1.35. What is the ratio of the Clean energy produced (as % of total energy) of Eritrea in 2000 to that in 2002?
Give a very brief answer. 1.06. What is the ratio of the Clean energy produced (as % of total energy) in Namibia in 2000 to that in 2002?
Make the answer very short. 1.06. What is the ratio of the Clean energy produced (as % of total energy) of Eritrea in 2000 to that in 2003?
Your response must be concise. 1.14. What is the ratio of the Clean energy produced (as % of total energy) in Iceland in 2000 to that in 2003?
Provide a short and direct response. 0.99. What is the ratio of the Clean energy produced (as % of total energy) of Namibia in 2000 to that in 2003?
Your response must be concise. 1.11. What is the ratio of the Clean energy produced (as % of total energy) of Eritrea in 2000 to that in 2004?
Offer a terse response. 1.05. What is the ratio of the Clean energy produced (as % of total energy) of Iceland in 2000 to that in 2004?
Offer a terse response. 0.99. What is the ratio of the Clean energy produced (as % of total energy) in Namibia in 2000 to that in 2004?
Make the answer very short. 1.24. What is the ratio of the Clean energy produced (as % of total energy) of Eritrea in 2001 to that in 2002?
Your answer should be very brief. 1.01. What is the ratio of the Clean energy produced (as % of total energy) in Iceland in 2001 to that in 2002?
Provide a succinct answer. 1.01. What is the ratio of the Clean energy produced (as % of total energy) in Namibia in 2001 to that in 2002?
Make the answer very short. 0.78. What is the ratio of the Clean energy produced (as % of total energy) in Eritrea in 2001 to that in 2003?
Keep it short and to the point. 1.08. What is the ratio of the Clean energy produced (as % of total energy) in Iceland in 2001 to that in 2003?
Ensure brevity in your answer.  1.01. What is the ratio of the Clean energy produced (as % of total energy) of Namibia in 2001 to that in 2003?
Offer a terse response. 0.82. What is the ratio of the Clean energy produced (as % of total energy) in Eritrea in 2001 to that in 2004?
Provide a succinct answer. 1. What is the ratio of the Clean energy produced (as % of total energy) of Iceland in 2001 to that in 2004?
Your answer should be very brief. 1.01. What is the ratio of the Clean energy produced (as % of total energy) in Namibia in 2001 to that in 2004?
Offer a very short reply. 0.91. What is the ratio of the Clean energy produced (as % of total energy) in Eritrea in 2002 to that in 2003?
Provide a short and direct response. 1.07. What is the ratio of the Clean energy produced (as % of total energy) of Iceland in 2002 to that in 2003?
Provide a short and direct response. 1. What is the ratio of the Clean energy produced (as % of total energy) in Namibia in 2002 to that in 2003?
Provide a short and direct response. 1.05. What is the ratio of the Clean energy produced (as % of total energy) in Eritrea in 2002 to that in 2004?
Ensure brevity in your answer.  0.99. What is the ratio of the Clean energy produced (as % of total energy) in Iceland in 2002 to that in 2004?
Your answer should be very brief. 1. What is the ratio of the Clean energy produced (as % of total energy) in Namibia in 2002 to that in 2004?
Provide a short and direct response. 1.17. What is the ratio of the Clean energy produced (as % of total energy) of Eritrea in 2003 to that in 2004?
Ensure brevity in your answer.  0.92. What is the ratio of the Clean energy produced (as % of total energy) of Namibia in 2003 to that in 2004?
Provide a succinct answer. 1.11. What is the difference between the highest and the second highest Clean energy produced (as % of total energy) in Eritrea?
Your answer should be very brief. 0. What is the difference between the highest and the second highest Clean energy produced (as % of total energy) in Iceland?
Provide a succinct answer. 0.64. What is the difference between the highest and the second highest Clean energy produced (as % of total energy) in Namibia?
Your answer should be compact. 0.63. What is the difference between the highest and the lowest Clean energy produced (as % of total energy) of Eritrea?
Your answer should be very brief. 0. What is the difference between the highest and the lowest Clean energy produced (as % of total energy) of Iceland?
Your answer should be very brief. 6.4. What is the difference between the highest and the lowest Clean energy produced (as % of total energy) in Namibia?
Your answer should be very brief. 6.71. 